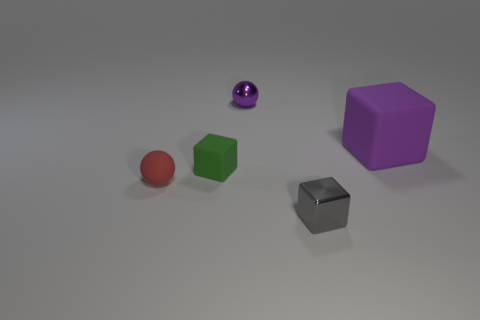Does the small metallic thing left of the gray shiny thing have the same shape as the small red matte thing that is behind the gray metallic object?
Your answer should be very brief. Yes. There is a metallic object to the right of the shiny object behind the small gray block; what is its shape?
Provide a short and direct response. Cube. What size is the object that is the same color as the metallic ball?
Keep it short and to the point. Large. Are there any large blue things that have the same material as the tiny red thing?
Offer a terse response. No. There is a tiny sphere in front of the large purple block; what material is it?
Offer a very short reply. Rubber. What is the material of the small green cube?
Provide a succinct answer. Rubber. Is the material of the small cube on the right side of the green rubber thing the same as the green thing?
Provide a succinct answer. No. Are there fewer things that are left of the purple rubber block than things?
Keep it short and to the point. Yes. There is a matte ball that is the same size as the gray block; what color is it?
Your response must be concise. Red. What number of small purple metal objects have the same shape as the small gray object?
Give a very brief answer. 0. 